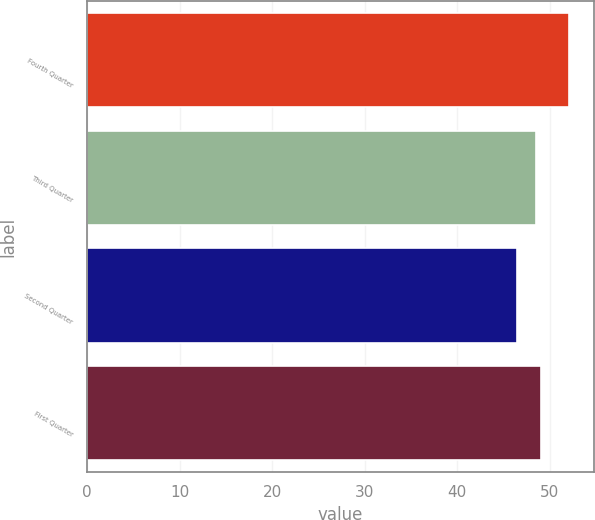Convert chart to OTSL. <chart><loc_0><loc_0><loc_500><loc_500><bar_chart><fcel>Fourth Quarter<fcel>Third Quarter<fcel>Second Quarter<fcel>First Quarter<nl><fcel>52.1<fcel>48.5<fcel>46.45<fcel>49.06<nl></chart> 